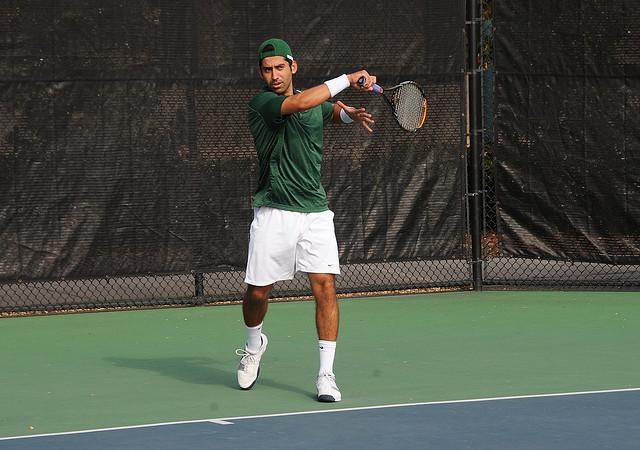What sport is this?
Give a very brief answer. Tennis. Is the man jumping or standing?
Answer briefly. Standing. Are those leaves on the tennis court?
Short answer required. No. What color is the court?
Give a very brief answer. Green. What race is the boy?
Write a very short answer. Hispanic. Is the man jumping?
Short answer required. No. Is this a famous tennis player?
Be succinct. No. Is this man sword fighting?
Keep it brief. No. What color is his shirt?
Answer briefly. Green. Is he serving the ball?
Keep it brief. No. 